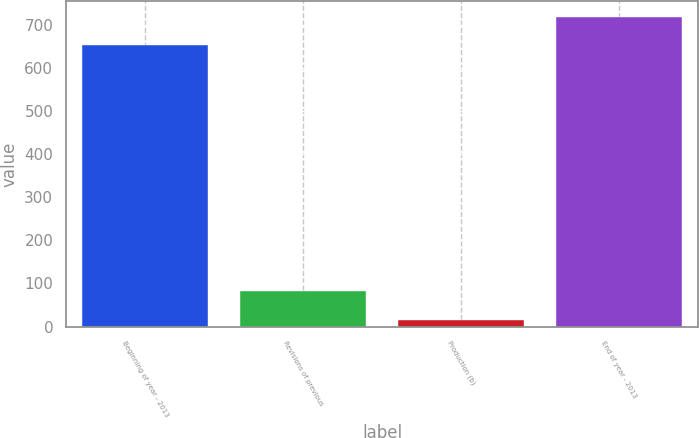Convert chart. <chart><loc_0><loc_0><loc_500><loc_500><bar_chart><fcel>Beginning of year - 2013<fcel>Revisions of previous<fcel>Production (b)<fcel>End of year - 2013<nl><fcel>653<fcel>81.5<fcel>15<fcel>719.5<nl></chart> 